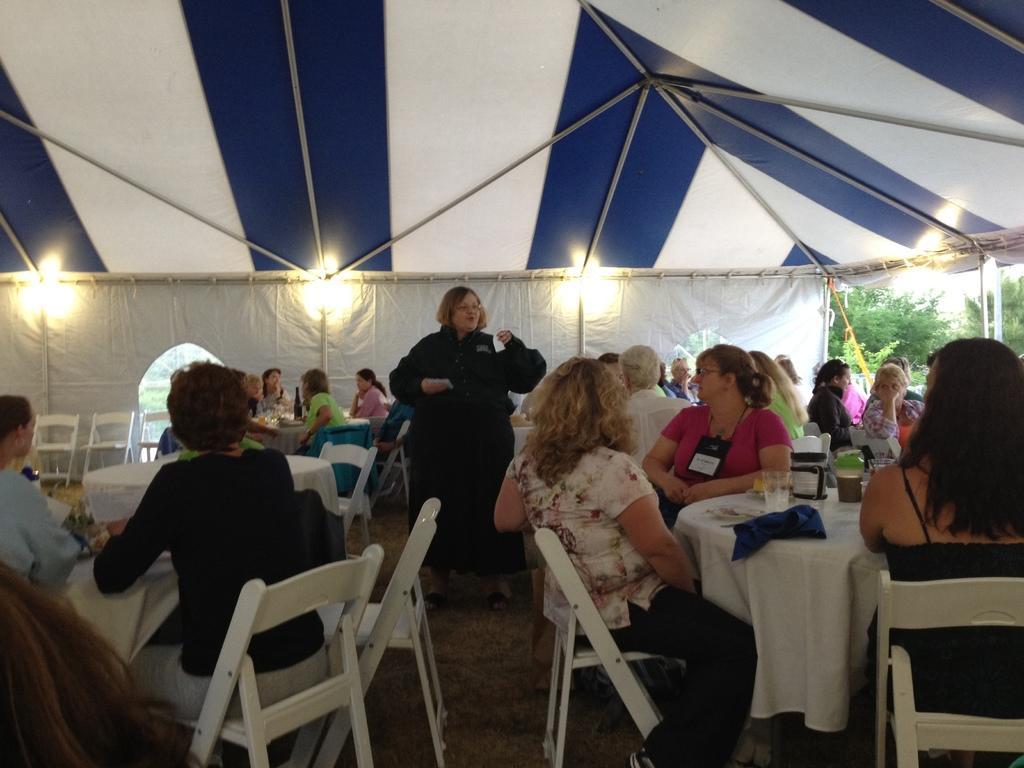Could you give a brief overview of what you see in this image? There are group of tables and chairs arranged under the tent. And the group people sitting on the chairs. there is a lady standing at the middle and talking to the crowd. beside the text there are so many trees. 